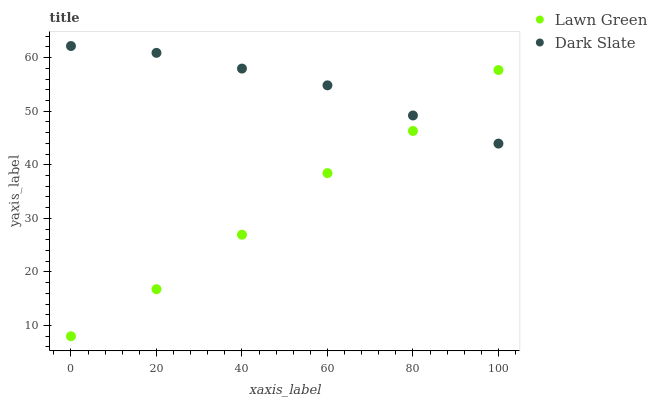Does Lawn Green have the minimum area under the curve?
Answer yes or no. Yes. Does Dark Slate have the maximum area under the curve?
Answer yes or no. Yes. Does Dark Slate have the minimum area under the curve?
Answer yes or no. No. Is Dark Slate the smoothest?
Answer yes or no. Yes. Is Lawn Green the roughest?
Answer yes or no. Yes. Is Dark Slate the roughest?
Answer yes or no. No. Does Lawn Green have the lowest value?
Answer yes or no. Yes. Does Dark Slate have the lowest value?
Answer yes or no. No. Does Dark Slate have the highest value?
Answer yes or no. Yes. Does Lawn Green intersect Dark Slate?
Answer yes or no. Yes. Is Lawn Green less than Dark Slate?
Answer yes or no. No. Is Lawn Green greater than Dark Slate?
Answer yes or no. No. 